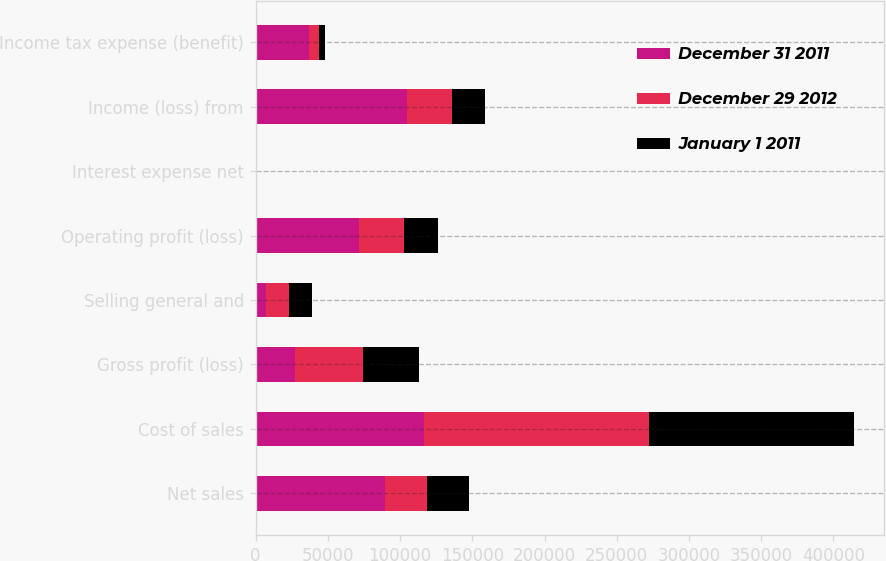<chart> <loc_0><loc_0><loc_500><loc_500><stacked_bar_chart><ecel><fcel>Net sales<fcel>Cost of sales<fcel>Gross profit (loss)<fcel>Selling general and<fcel>Operating profit (loss)<fcel>Interest expense net<fcel>Income (loss) from<fcel>Income tax expense (benefit)<nl><fcel>December 31 2011<fcel>89686<fcel>116798<fcel>27112<fcel>7200<fcel>71737<fcel>5<fcel>104571<fcel>36809<nl><fcel>December 29 2012<fcel>29083.5<fcel>155689<fcel>47163<fcel>16009<fcel>31154<fcel>99<fcel>31055<fcel>6936<nl><fcel>January 1 2011<fcel>29083.5<fcel>141770<fcel>38931<fcel>15608<fcel>23323<fcel>93<fcel>23230<fcel>4549<nl></chart> 